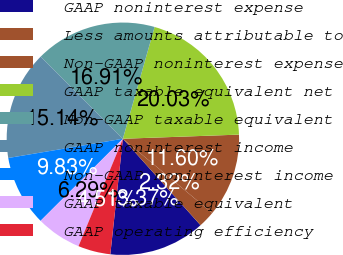Convert chart. <chart><loc_0><loc_0><loc_500><loc_500><pie_chart><fcel>GAAP noninterest expense<fcel>Less amounts attributable to<fcel>Non-GAAP noninterest expense<fcel>GAAP taxable equivalent net<fcel>Non-GAAP taxable equivalent<fcel>GAAP noninterest income<fcel>Non-GAAP noninterest income<fcel>GAAP taxable equivalent<fcel>GAAP operating efficiency<nl><fcel>13.37%<fcel>2.32%<fcel>11.6%<fcel>20.03%<fcel>16.91%<fcel>15.14%<fcel>9.83%<fcel>6.29%<fcel>4.51%<nl></chart> 